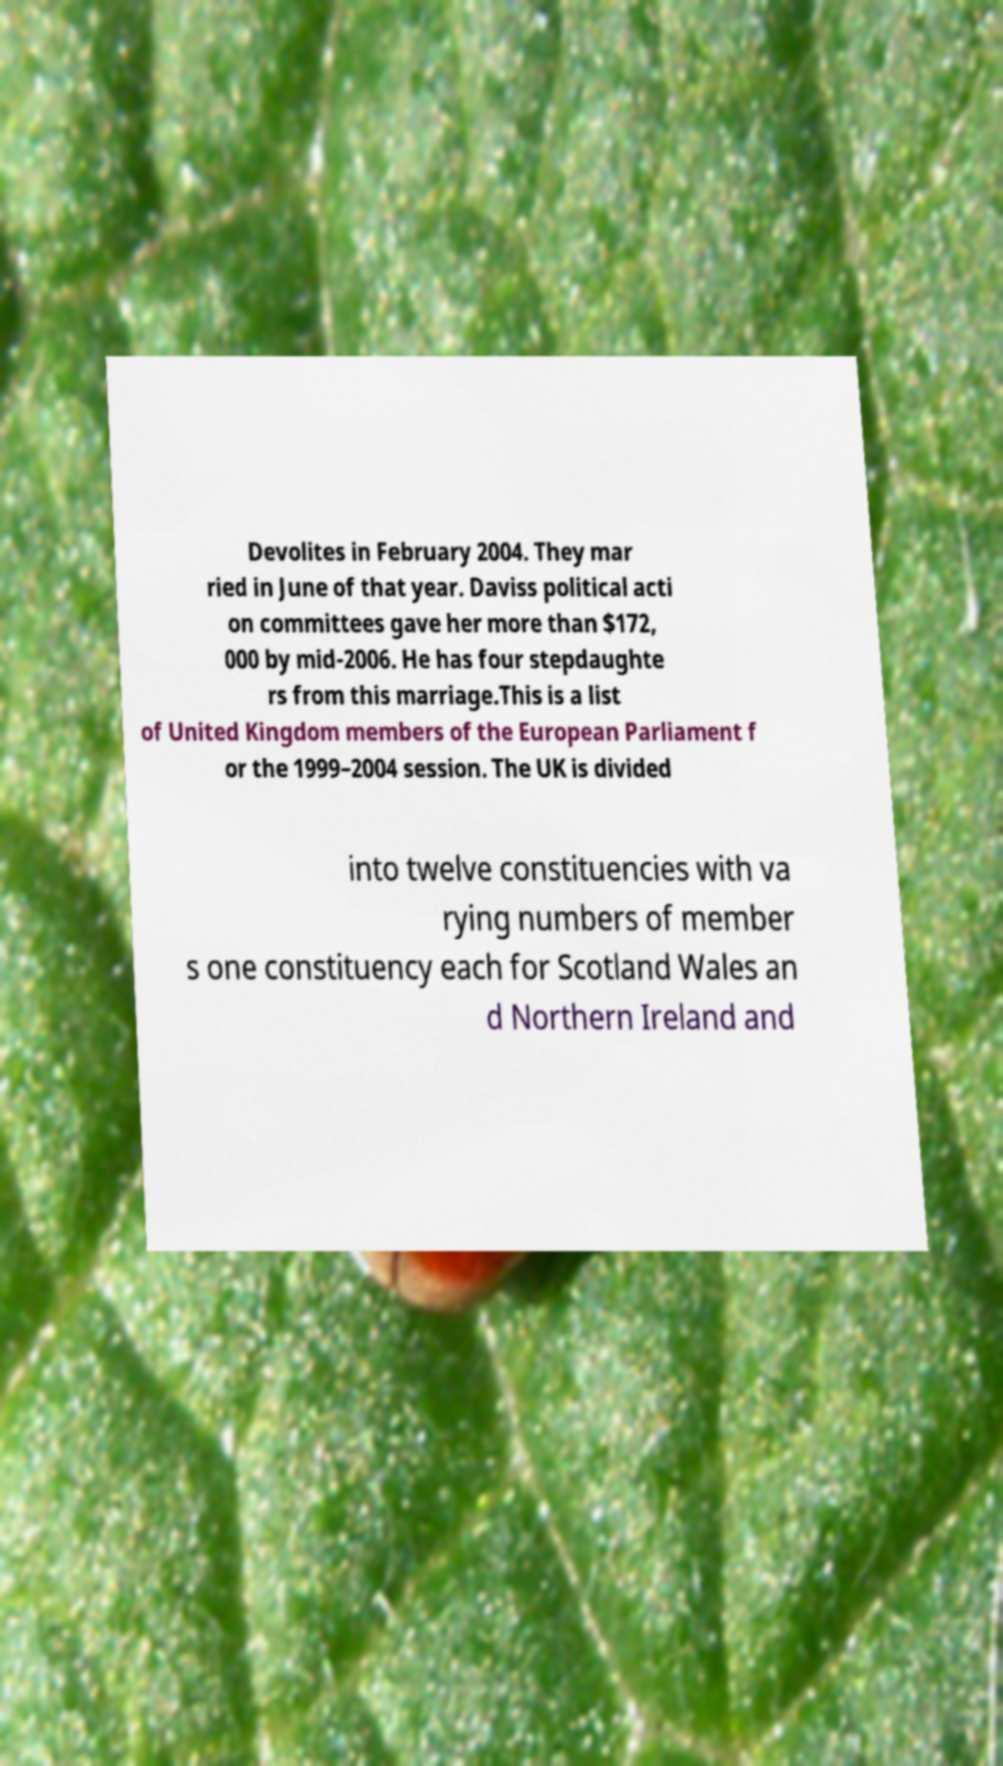Can you accurately transcribe the text from the provided image for me? Devolites in February 2004. They mar ried in June of that year. Daviss political acti on committees gave her more than $172, 000 by mid-2006. He has four stepdaughte rs from this marriage.This is a list of United Kingdom members of the European Parliament f or the 1999–2004 session. The UK is divided into twelve constituencies with va rying numbers of member s one constituency each for Scotland Wales an d Northern Ireland and 